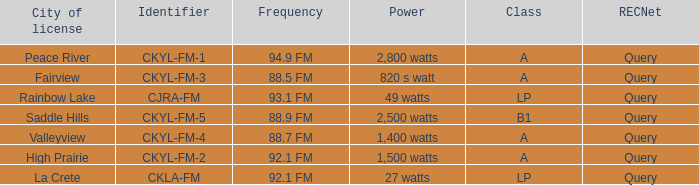What is the power with 88.5 fm frequency 820 s watt. 